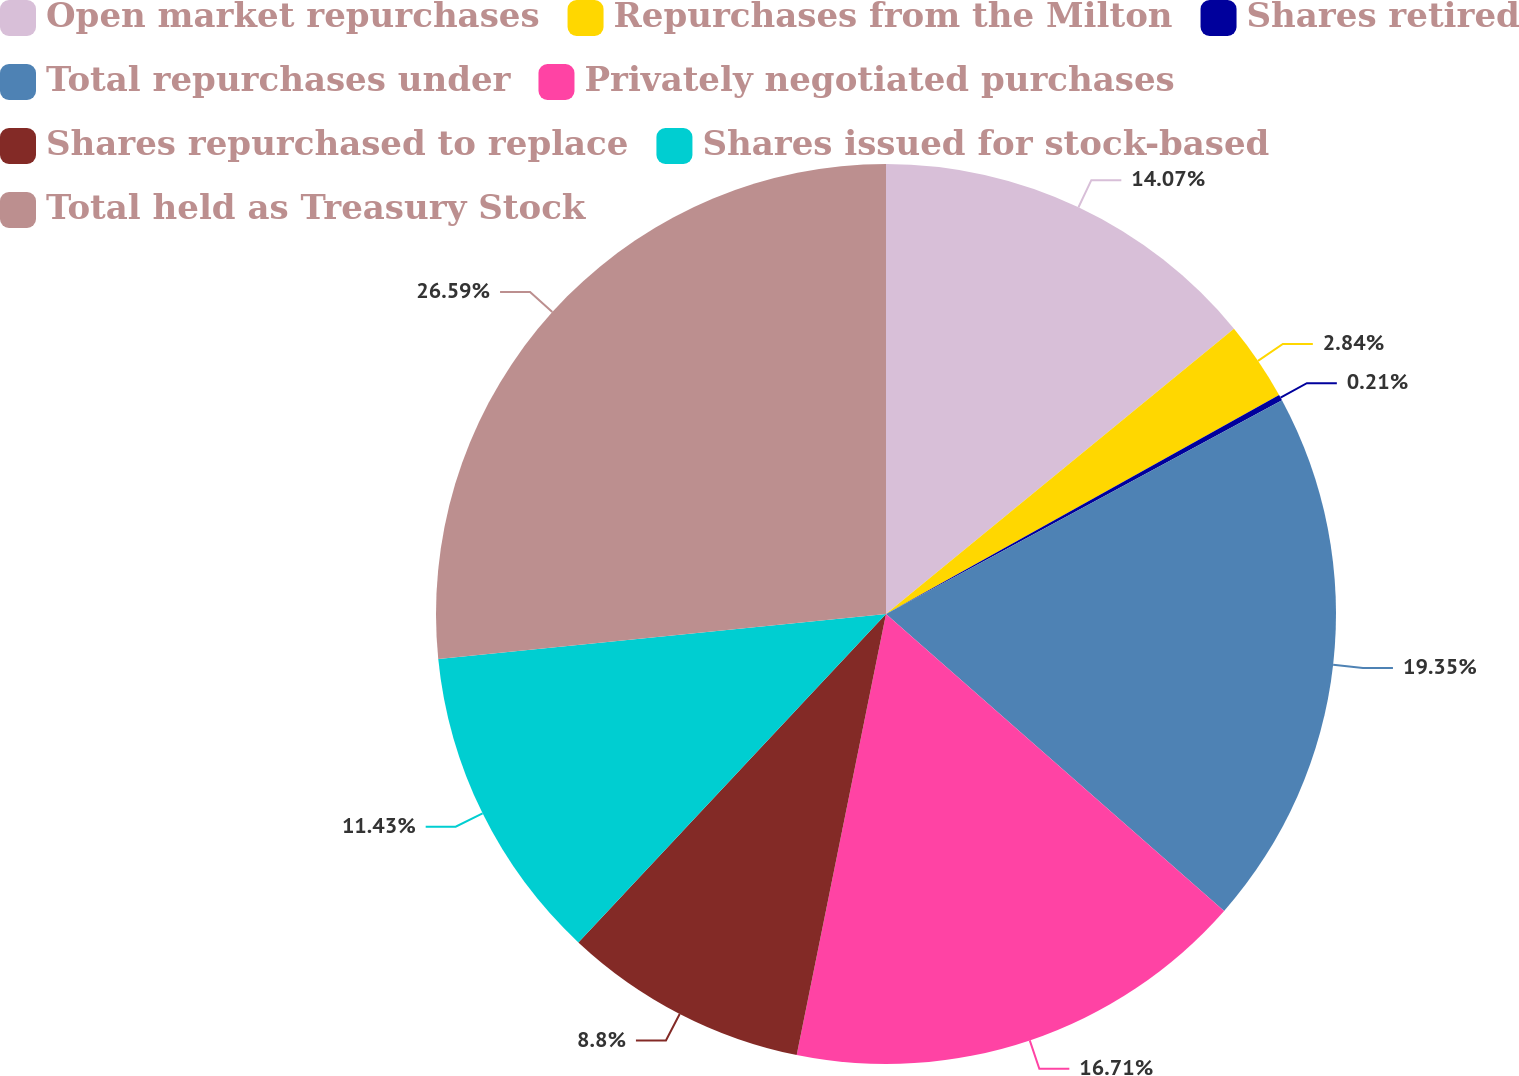Convert chart to OTSL. <chart><loc_0><loc_0><loc_500><loc_500><pie_chart><fcel>Open market repurchases<fcel>Repurchases from the Milton<fcel>Shares retired<fcel>Total repurchases under<fcel>Privately negotiated purchases<fcel>Shares repurchased to replace<fcel>Shares issued for stock-based<fcel>Total held as Treasury Stock<nl><fcel>14.07%<fcel>2.84%<fcel>0.21%<fcel>19.35%<fcel>16.71%<fcel>8.8%<fcel>11.43%<fcel>26.59%<nl></chart> 